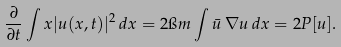Convert formula to latex. <formula><loc_0><loc_0><loc_500><loc_500>\frac { \partial } { \partial t } \int x | u ( x , t ) | ^ { 2 } \, d x = 2 \i m \int \bar { u } \, \nabla u \, d x = 2 P [ u ] .</formula> 